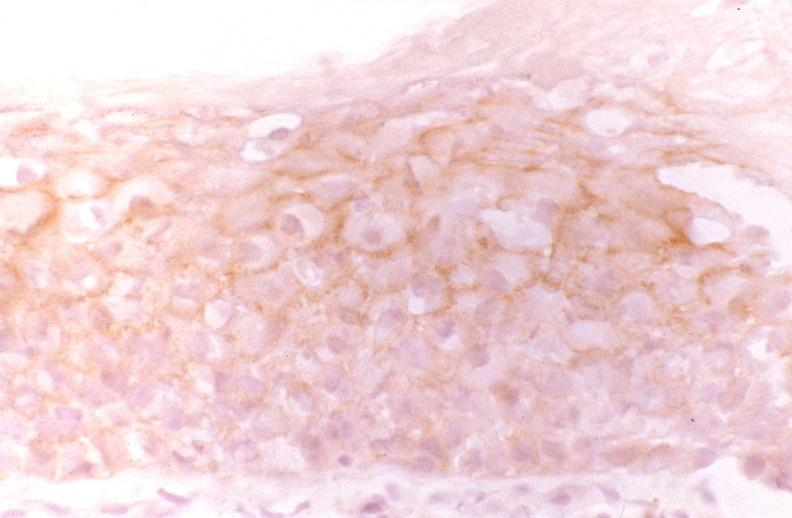s gastrointestinal present?
Answer the question using a single word or phrase. Yes 